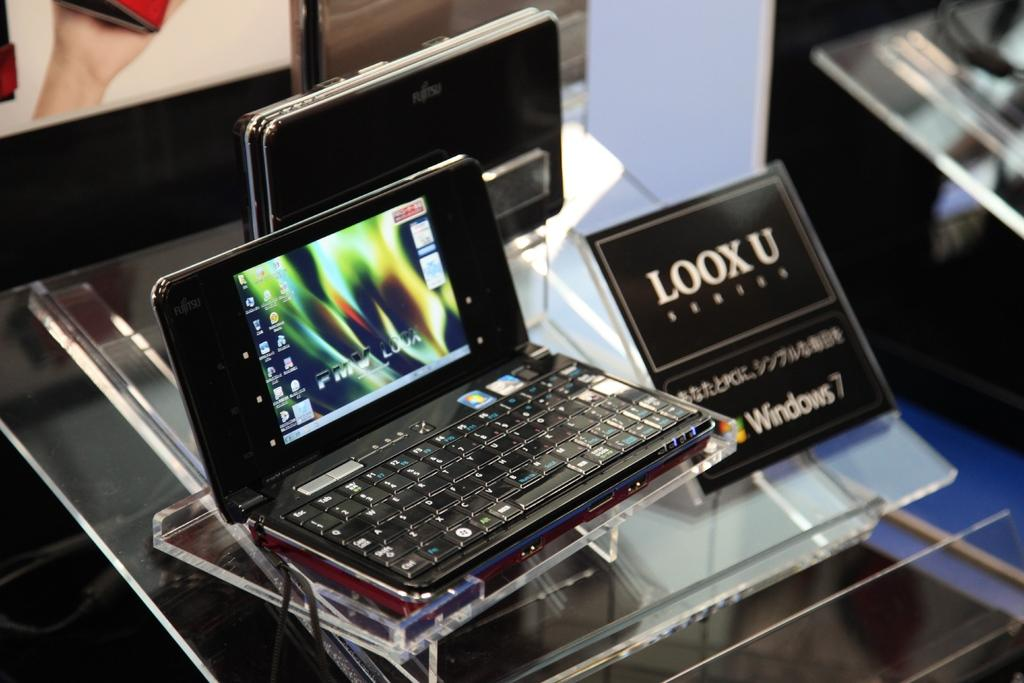<image>
Provide a brief description of the given image. A very small lap top the size of a cell phone on display with a sign next to it that says Loox  U. 